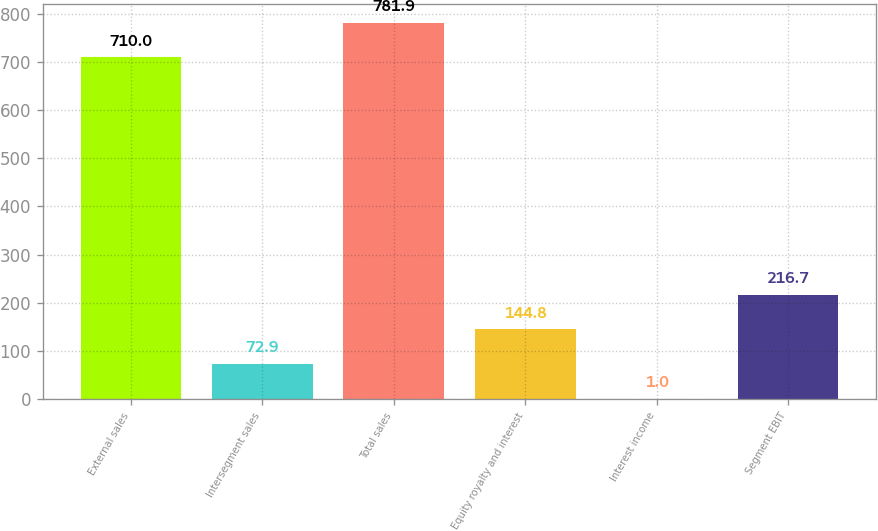Convert chart to OTSL. <chart><loc_0><loc_0><loc_500><loc_500><bar_chart><fcel>External sales<fcel>Intersegment sales<fcel>Total sales<fcel>Equity royalty and interest<fcel>Interest income<fcel>Segment EBIT<nl><fcel>710<fcel>72.9<fcel>781.9<fcel>144.8<fcel>1<fcel>216.7<nl></chart> 